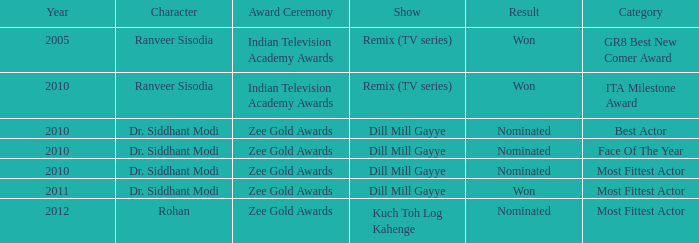Which show was nominated for the ITA Milestone Award at the Indian Television Academy Awards? Remix (TV series). 